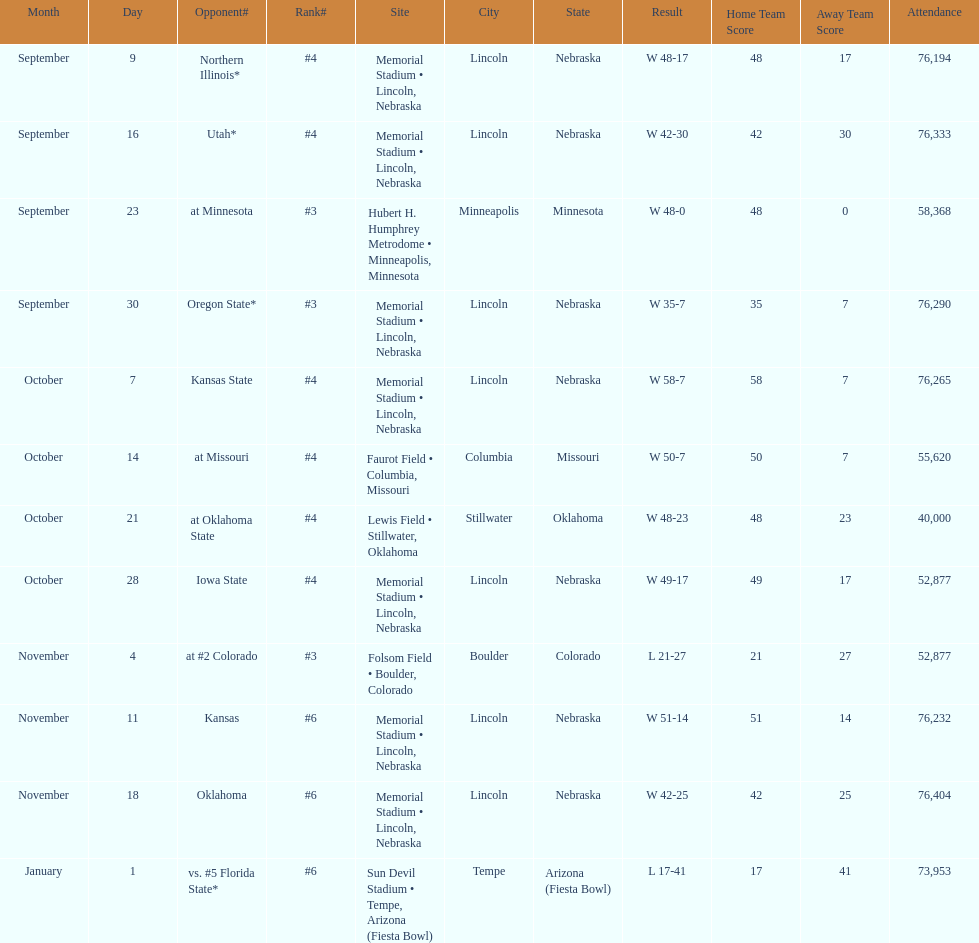Which month is listed the least on this chart? January. 